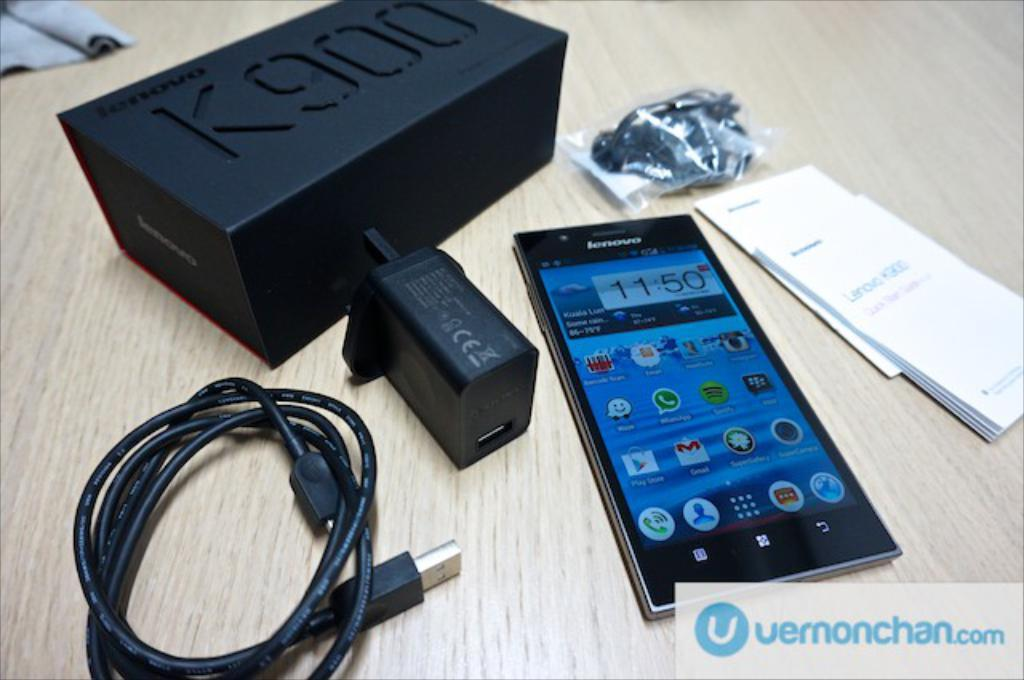<image>
Relay a brief, clear account of the picture shown. A Lenovo brand smartphone with cords beside it and a K900 box above the phone 